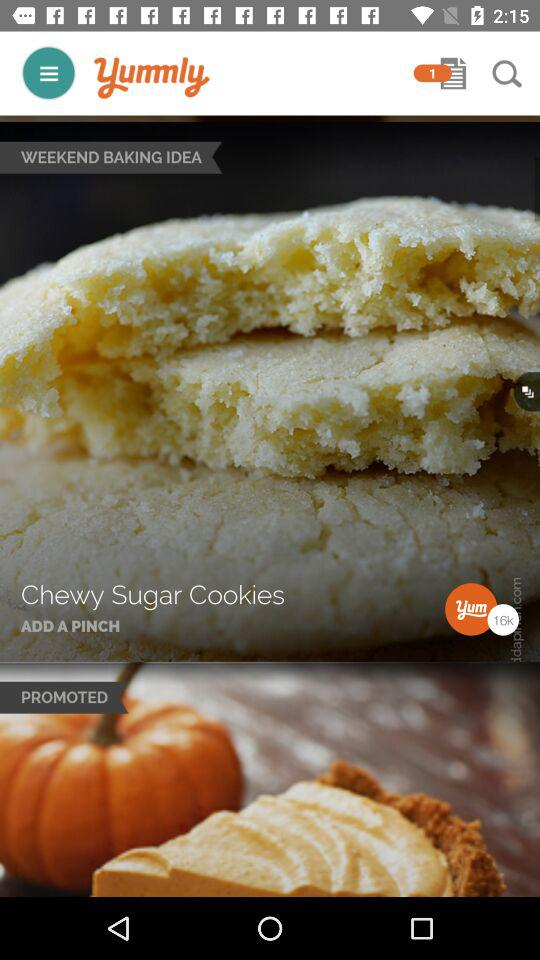What is the name of the application? The name of the application is "Yummly". 